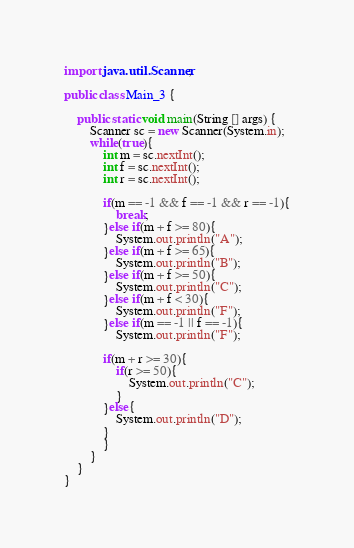<code> <loc_0><loc_0><loc_500><loc_500><_Java_>import java.util.Scanner;

public class Main_3 {
	
	public static void main(String [] args) {
		Scanner sc = new Scanner(System.in);
		while(true){
			int m = sc.nextInt();
			int f = sc.nextInt();
			int r = sc.nextInt();
			
			if(m == -1 && f == -1 && r == -1){
				break;
			}else if(m + f >= 80){
				System.out.println("A");
			}else if(m + f >= 65){
				System.out.println("B");
			}else if(m + f >= 50){
				System.out.println("C");
			}else if(m + f < 30){
				System.out.println("F");
			}else if(m == -1 || f == -1){
				System.out.println("F");
			
			if(m + r >= 30){
				if(r >= 50){
					System.out.println("C");
				}
			}else{
				System.out.println("D");
			}
			}
		}
	}
}
</code> 